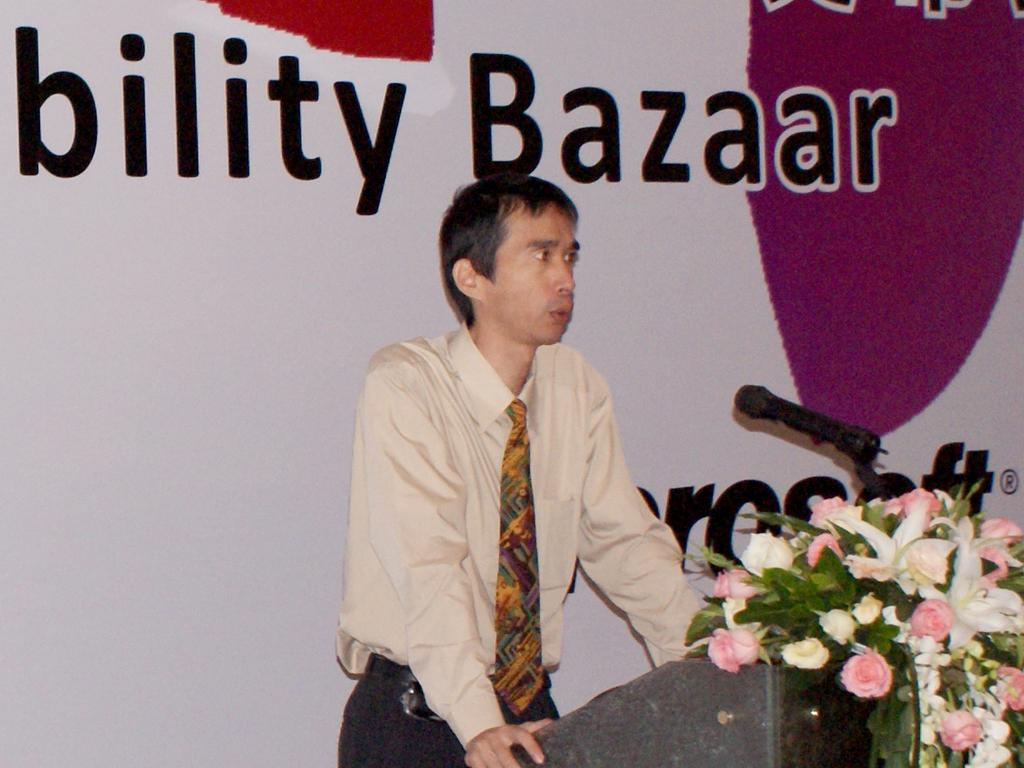What is the man in the foreground of the image doing? The man is standing near a podium in the foreground of the image. What is on the podium that the man is standing near? Flowers and a microphone are placed on the podium. What can be seen in the background of the image? In the background, there is a banner wall. What type of art can be seen in the mist in the image? There is no mist or art present in the image. 